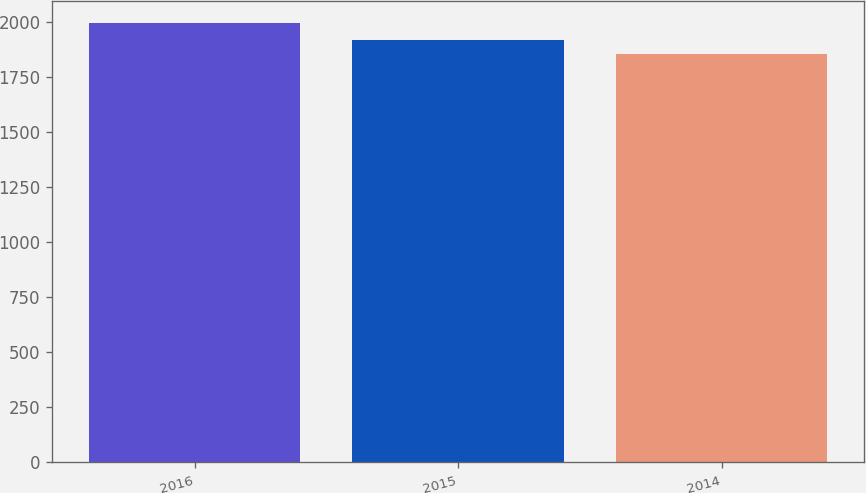<chart> <loc_0><loc_0><loc_500><loc_500><bar_chart><fcel>2016<fcel>2015<fcel>2014<nl><fcel>1997<fcel>1920<fcel>1855<nl></chart> 